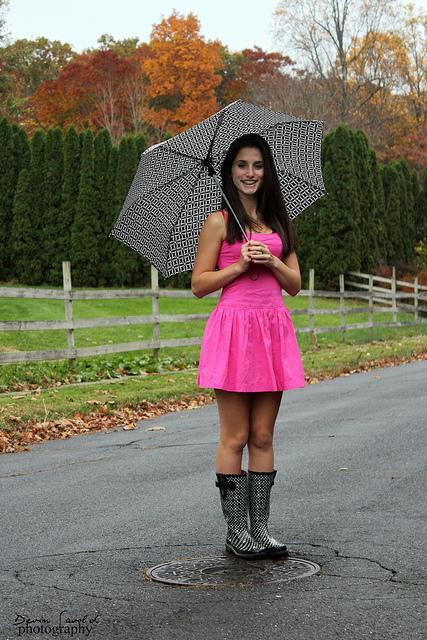Are there polka dots on the umbrella?
Short answer required. Yes. What kind of green plant is in the background?
Write a very short answer. Grass. What is the girl standing on?
Quick response, please. Street. Are there dots here?
Concise answer only. Yes. Does she have a big bag?
Give a very brief answer. No. What is the tree behind her?
Be succinct. Evergreen. How old is the girl?
Quick response, please. 19. What color is her umbrella?
Quick response, please. Black and white. What is in her hair?
Quick response, please. Nothing. What color is the girl's hair?
Keep it brief. Black. What is the woman doing with her legs?
Quick response, please. Standing. Does the umbrella match the color of her boots?
Be succinct. Yes. What color is the girls dress?
Keep it brief. Pink. 